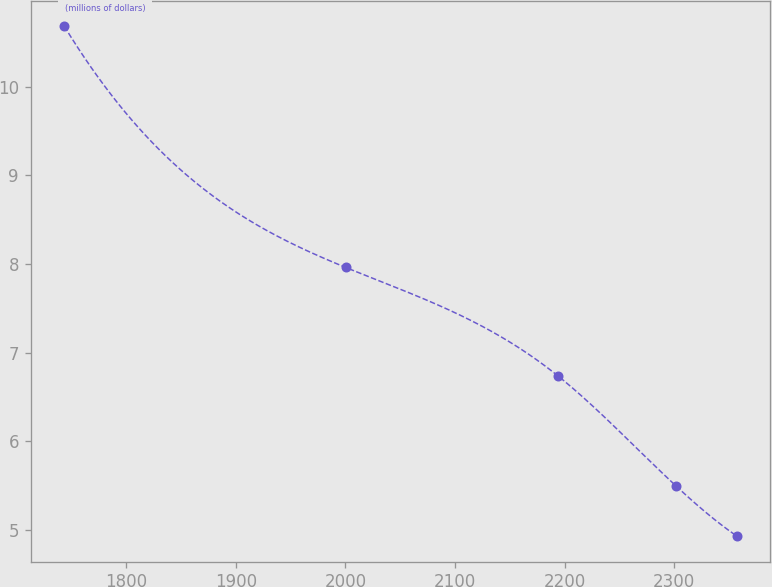<chart> <loc_0><loc_0><loc_500><loc_500><line_chart><ecel><fcel>(millions of dollars)<nl><fcel>1743.25<fcel>10.68<nl><fcel>2000.17<fcel>7.96<nl><fcel>2193.65<fcel>6.74<nl><fcel>2301.36<fcel>5.5<nl><fcel>2357.33<fcel>4.93<nl></chart> 